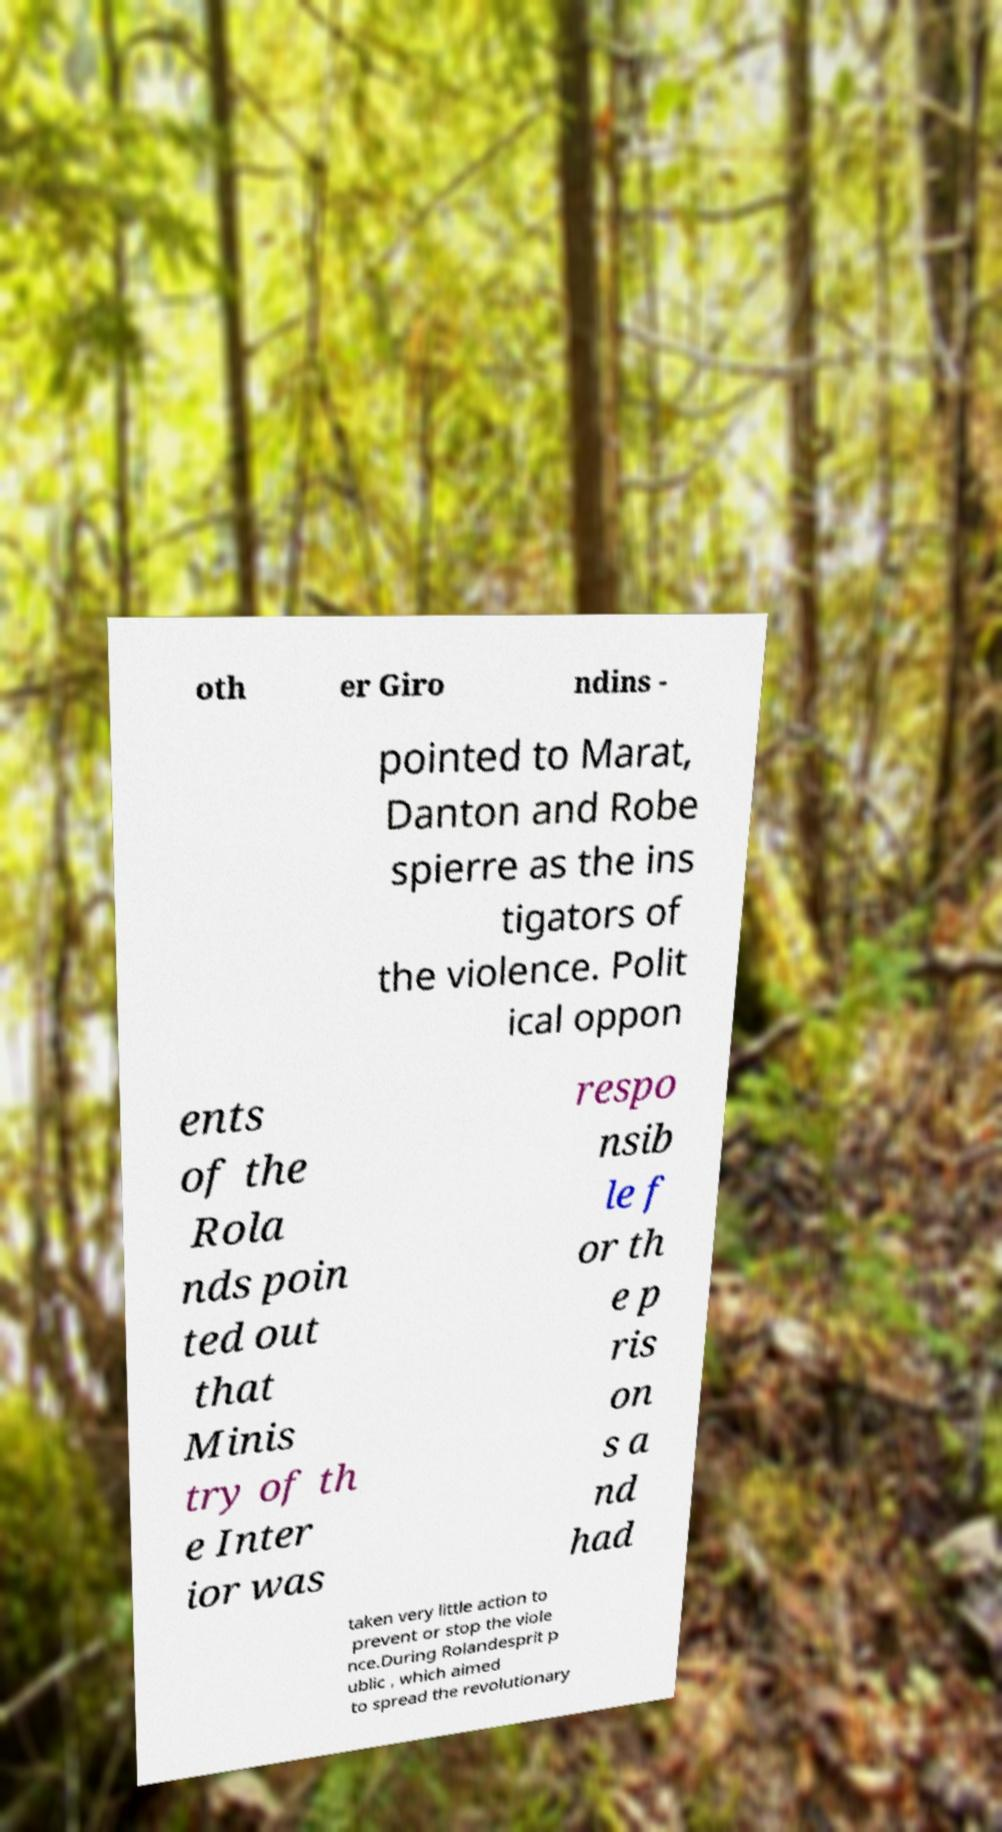Can you accurately transcribe the text from the provided image for me? oth er Giro ndins - pointed to Marat, Danton and Robe spierre as the ins tigators of the violence. Polit ical oppon ents of the Rola nds poin ted out that Minis try of th e Inter ior was respo nsib le f or th e p ris on s a nd had taken very little action to prevent or stop the viole nce.During Rolandesprit p ublic , which aimed to spread the revolutionary 